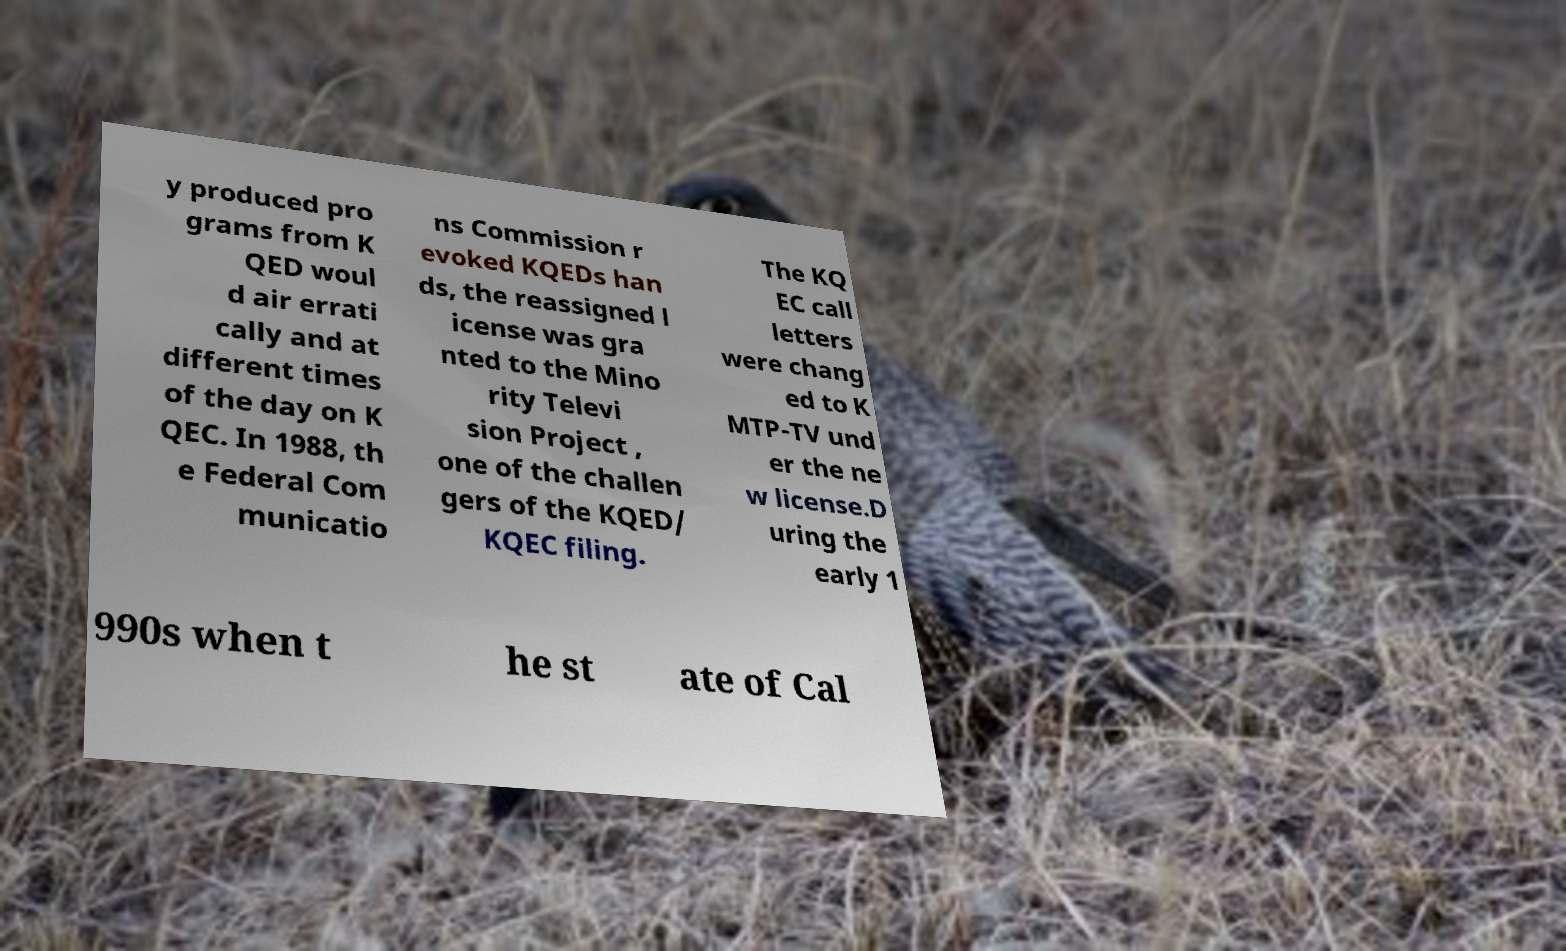I need the written content from this picture converted into text. Can you do that? y produced pro grams from K QED woul d air errati cally and at different times of the day on K QEC. In 1988, th e Federal Com municatio ns Commission r evoked KQEDs han ds, the reassigned l icense was gra nted to the Mino rity Televi sion Project , one of the challen gers of the KQED/ KQEC filing. The KQ EC call letters were chang ed to K MTP-TV und er the ne w license.D uring the early 1 990s when t he st ate of Cal 